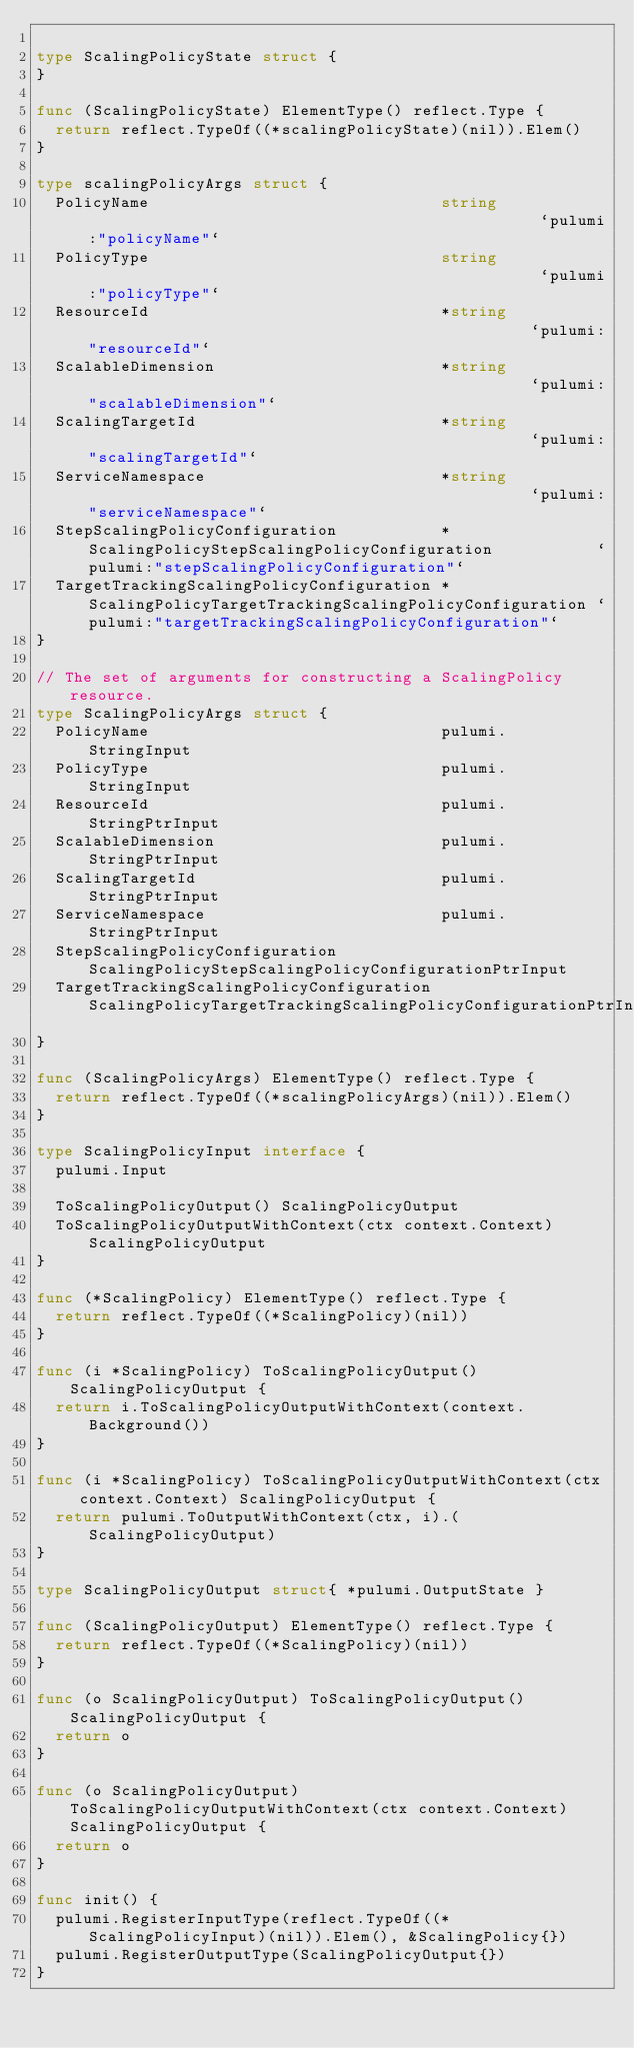Convert code to text. <code><loc_0><loc_0><loc_500><loc_500><_Go_>
type ScalingPolicyState struct {
}

func (ScalingPolicyState) ElementType() reflect.Type {
	return reflect.TypeOf((*scalingPolicyState)(nil)).Elem()
}

type scalingPolicyArgs struct {
	PolicyName                               string                                                 `pulumi:"policyName"`
	PolicyType                               string                                                 `pulumi:"policyType"`
	ResourceId                               *string                                                `pulumi:"resourceId"`
	ScalableDimension                        *string                                                `pulumi:"scalableDimension"`
	ScalingTargetId                          *string                                                `pulumi:"scalingTargetId"`
	ServiceNamespace                         *string                                                `pulumi:"serviceNamespace"`
	StepScalingPolicyConfiguration           *ScalingPolicyStepScalingPolicyConfiguration           `pulumi:"stepScalingPolicyConfiguration"`
	TargetTrackingScalingPolicyConfiguration *ScalingPolicyTargetTrackingScalingPolicyConfiguration `pulumi:"targetTrackingScalingPolicyConfiguration"`
}

// The set of arguments for constructing a ScalingPolicy resource.
type ScalingPolicyArgs struct {
	PolicyName                               pulumi.StringInput
	PolicyType                               pulumi.StringInput
	ResourceId                               pulumi.StringPtrInput
	ScalableDimension                        pulumi.StringPtrInput
	ScalingTargetId                          pulumi.StringPtrInput
	ServiceNamespace                         pulumi.StringPtrInput
	StepScalingPolicyConfiguration           ScalingPolicyStepScalingPolicyConfigurationPtrInput
	TargetTrackingScalingPolicyConfiguration ScalingPolicyTargetTrackingScalingPolicyConfigurationPtrInput
}

func (ScalingPolicyArgs) ElementType() reflect.Type {
	return reflect.TypeOf((*scalingPolicyArgs)(nil)).Elem()
}

type ScalingPolicyInput interface {
	pulumi.Input

	ToScalingPolicyOutput() ScalingPolicyOutput
	ToScalingPolicyOutputWithContext(ctx context.Context) ScalingPolicyOutput
}

func (*ScalingPolicy) ElementType() reflect.Type {
	return reflect.TypeOf((*ScalingPolicy)(nil))
}

func (i *ScalingPolicy) ToScalingPolicyOutput() ScalingPolicyOutput {
	return i.ToScalingPolicyOutputWithContext(context.Background())
}

func (i *ScalingPolicy) ToScalingPolicyOutputWithContext(ctx context.Context) ScalingPolicyOutput {
	return pulumi.ToOutputWithContext(ctx, i).(ScalingPolicyOutput)
}

type ScalingPolicyOutput struct{ *pulumi.OutputState }

func (ScalingPolicyOutput) ElementType() reflect.Type {
	return reflect.TypeOf((*ScalingPolicy)(nil))
}

func (o ScalingPolicyOutput) ToScalingPolicyOutput() ScalingPolicyOutput {
	return o
}

func (o ScalingPolicyOutput) ToScalingPolicyOutputWithContext(ctx context.Context) ScalingPolicyOutput {
	return o
}

func init() {
	pulumi.RegisterInputType(reflect.TypeOf((*ScalingPolicyInput)(nil)).Elem(), &ScalingPolicy{})
	pulumi.RegisterOutputType(ScalingPolicyOutput{})
}
</code> 